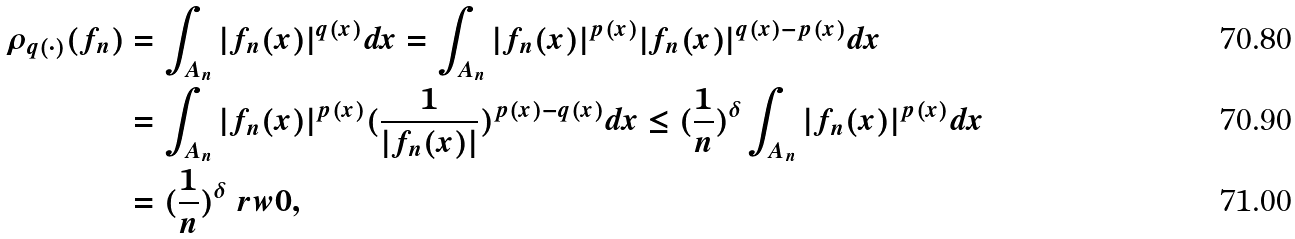Convert formula to latex. <formula><loc_0><loc_0><loc_500><loc_500>\rho _ { q ( \cdot ) } ( f _ { n } ) & = \int _ { A _ { n } } | f _ { n } ( x ) | ^ { q ( x ) } d x = \int _ { A _ { n } } | f _ { n } ( x ) | ^ { p ( x ) } | f _ { n } ( x ) | ^ { q ( x ) - p ( x ) } d x \\ & = \int _ { A _ { n } } | f _ { n } ( x ) | ^ { p ( x ) } ( \frac { 1 } { | f _ { n } ( x ) | } ) ^ { p ( x ) - q ( x ) } d x \leq ( \frac { 1 } { n } ) ^ { \delta } \int _ { A _ { n } } | f _ { n } ( x ) | ^ { p ( x ) } d x \\ & = ( \frac { 1 } { n } ) ^ { \delta } \ r w 0 ,</formula> 